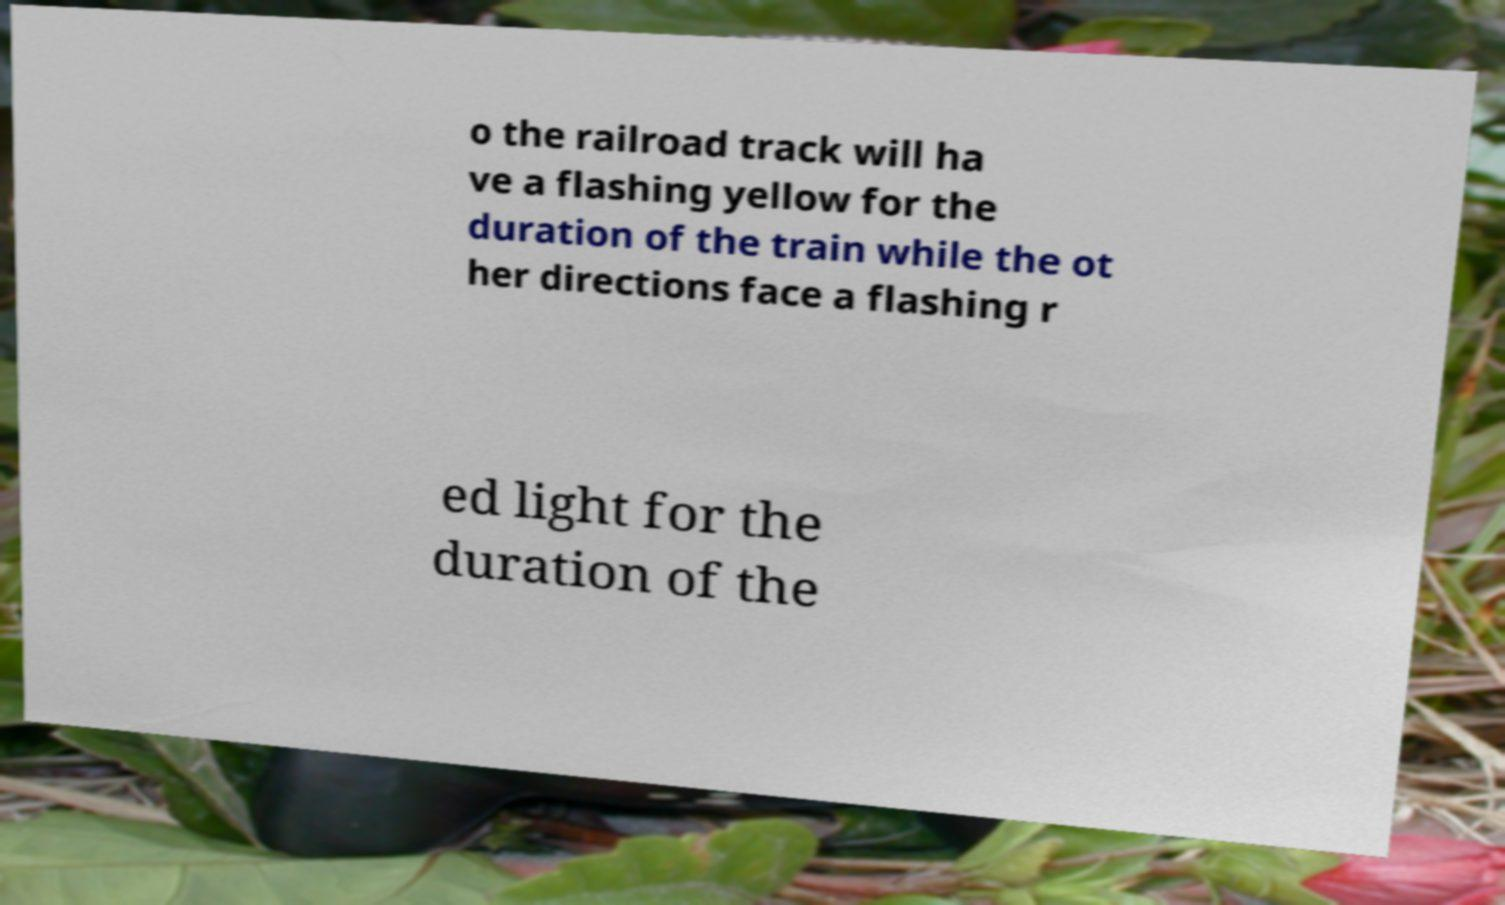Could you assist in decoding the text presented in this image and type it out clearly? o the railroad track will ha ve a flashing yellow for the duration of the train while the ot her directions face a flashing r ed light for the duration of the 